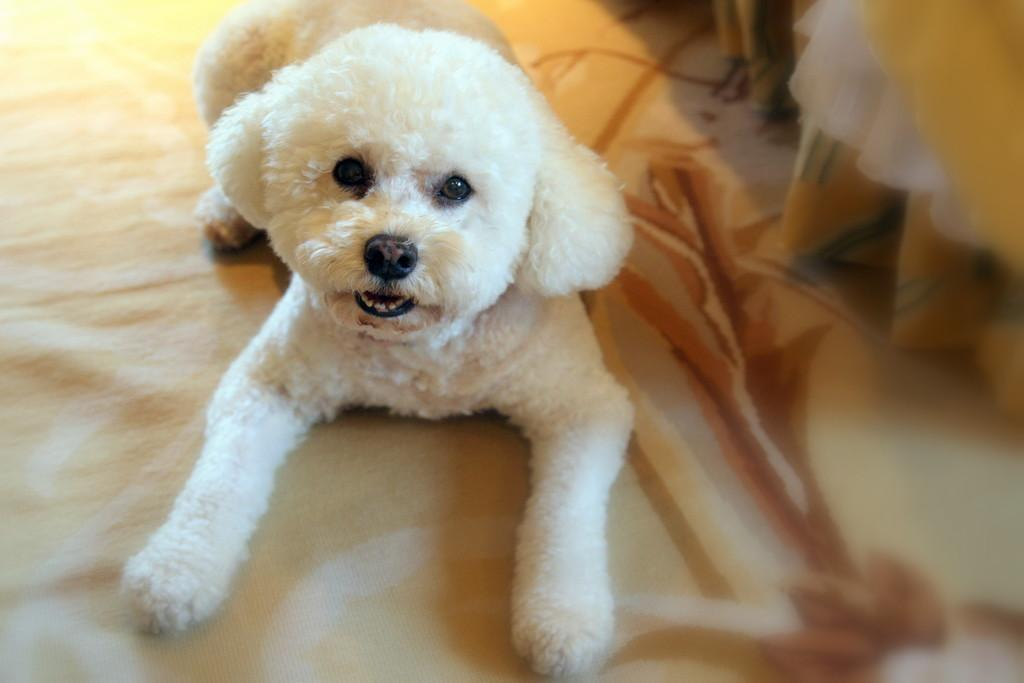What type of animal is in the image? There is a white puppy in the image. What is the position of the puppy in the image? The puppy is laying on the floor. What is covering the floor in the image? The floor has a carpet on it. What type of cheese is placed on top of the puppy in the image? There is no cheese present in the image, and the puppy is not interacting with any cheese. 